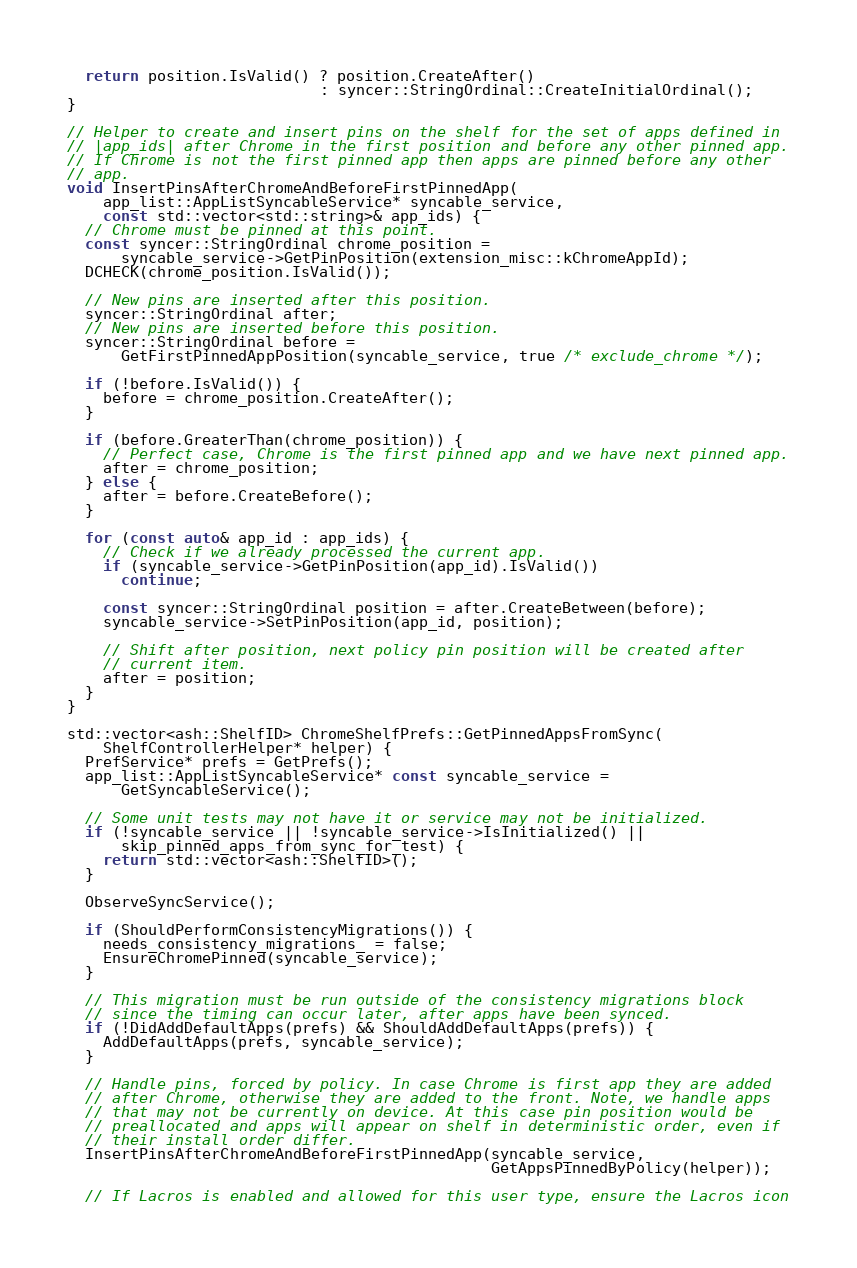<code> <loc_0><loc_0><loc_500><loc_500><_C++_>
  return position.IsValid() ? position.CreateAfter()
                            : syncer::StringOrdinal::CreateInitialOrdinal();
}

// Helper to create and insert pins on the shelf for the set of apps defined in
// |app_ids| after Chrome in the first position and before any other pinned app.
// If Chrome is not the first pinned app then apps are pinned before any other
// app.
void InsertPinsAfterChromeAndBeforeFirstPinnedApp(
    app_list::AppListSyncableService* syncable_service,
    const std::vector<std::string>& app_ids) {
  // Chrome must be pinned at this point.
  const syncer::StringOrdinal chrome_position =
      syncable_service->GetPinPosition(extension_misc::kChromeAppId);
  DCHECK(chrome_position.IsValid());

  // New pins are inserted after this position.
  syncer::StringOrdinal after;
  // New pins are inserted before this position.
  syncer::StringOrdinal before =
      GetFirstPinnedAppPosition(syncable_service, true /* exclude_chrome */);

  if (!before.IsValid()) {
    before = chrome_position.CreateAfter();
  }

  if (before.GreaterThan(chrome_position)) {
    // Perfect case, Chrome is the first pinned app and we have next pinned app.
    after = chrome_position;
  } else {
    after = before.CreateBefore();
  }

  for (const auto& app_id : app_ids) {
    // Check if we already processed the current app.
    if (syncable_service->GetPinPosition(app_id).IsValid())
      continue;

    const syncer::StringOrdinal position = after.CreateBetween(before);
    syncable_service->SetPinPosition(app_id, position);

    // Shift after position, next policy pin position will be created after
    // current item.
    after = position;
  }
}

std::vector<ash::ShelfID> ChromeShelfPrefs::GetPinnedAppsFromSync(
    ShelfControllerHelper* helper) {
  PrefService* prefs = GetPrefs();
  app_list::AppListSyncableService* const syncable_service =
      GetSyncableService();

  // Some unit tests may not have it or service may not be initialized.
  if (!syncable_service || !syncable_service->IsInitialized() ||
      skip_pinned_apps_from_sync_for_test) {
    return std::vector<ash::ShelfID>();
  }

  ObserveSyncService();

  if (ShouldPerformConsistencyMigrations()) {
    needs_consistency_migrations_ = false;
    EnsureChromePinned(syncable_service);
  }

  // This migration must be run outside of the consistency migrations block
  // since the timing can occur later, after apps have been synced.
  if (!DidAddDefaultApps(prefs) && ShouldAddDefaultApps(prefs)) {
    AddDefaultApps(prefs, syncable_service);
  }

  // Handle pins, forced by policy. In case Chrome is first app they are added
  // after Chrome, otherwise they are added to the front. Note, we handle apps
  // that may not be currently on device. At this case pin position would be
  // preallocated and apps will appear on shelf in deterministic order, even if
  // their install order differ.
  InsertPinsAfterChromeAndBeforeFirstPinnedApp(syncable_service,
                                               GetAppsPinnedByPolicy(helper));

  // If Lacros is enabled and allowed for this user type, ensure the Lacros icon</code> 